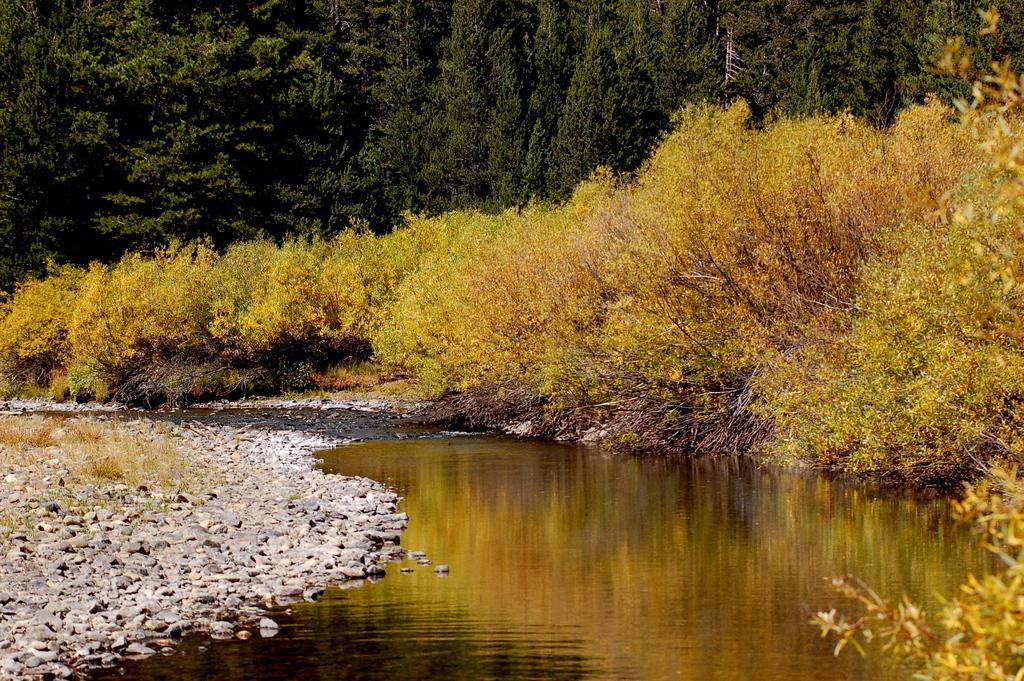Describe this image in one or two sentences. At the bottom, we see water and this water might be in the lake. On the left side, we see the trees and the stones. We see the reflections of trees in the water. On the right side, we see the trees. There are trees in the background. 